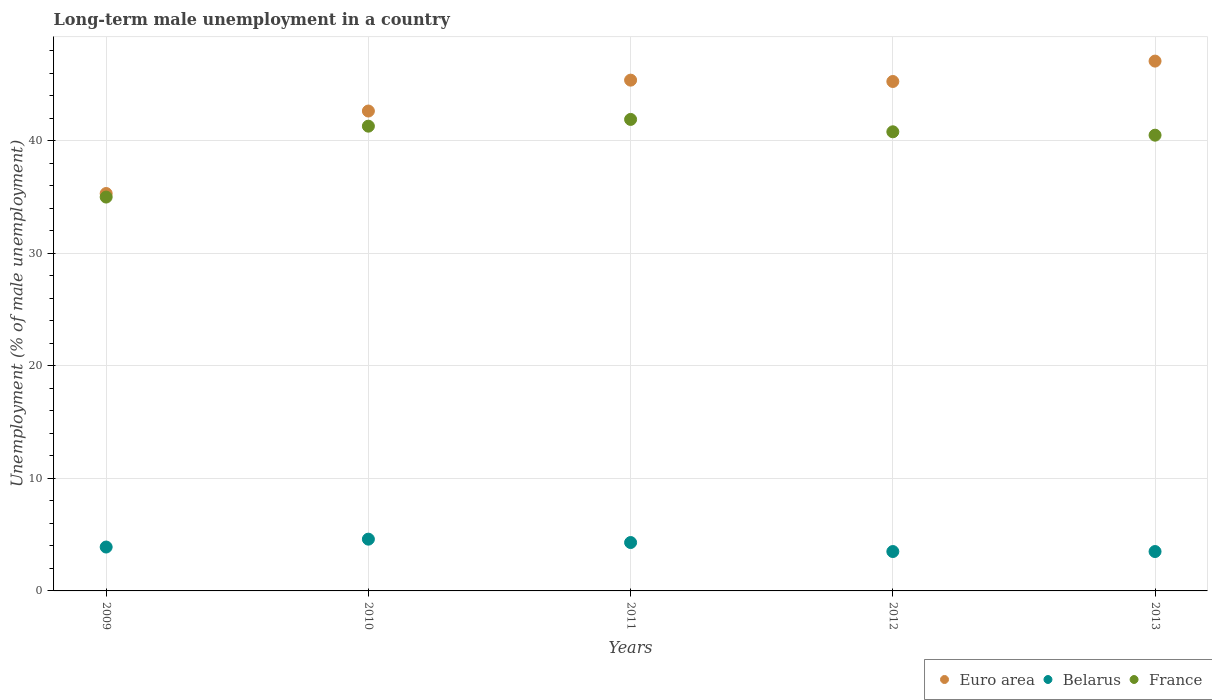What is the percentage of long-term unemployed male population in France in 2009?
Offer a terse response. 35. Across all years, what is the maximum percentage of long-term unemployed male population in France?
Make the answer very short. 41.9. Across all years, what is the minimum percentage of long-term unemployed male population in Euro area?
Keep it short and to the point. 35.32. In which year was the percentage of long-term unemployed male population in France maximum?
Your response must be concise. 2011. In which year was the percentage of long-term unemployed male population in France minimum?
Ensure brevity in your answer.  2009. What is the total percentage of long-term unemployed male population in Belarus in the graph?
Make the answer very short. 19.8. What is the difference between the percentage of long-term unemployed male population in France in 2011 and that in 2013?
Offer a very short reply. 1.4. What is the difference between the percentage of long-term unemployed male population in Euro area in 2013 and the percentage of long-term unemployed male population in France in 2009?
Offer a terse response. 12.08. What is the average percentage of long-term unemployed male population in France per year?
Provide a succinct answer. 39.9. In the year 2011, what is the difference between the percentage of long-term unemployed male population in France and percentage of long-term unemployed male population in Belarus?
Offer a terse response. 37.6. In how many years, is the percentage of long-term unemployed male population in Euro area greater than 2 %?
Offer a terse response. 5. What is the ratio of the percentage of long-term unemployed male population in Euro area in 2009 to that in 2010?
Provide a succinct answer. 0.83. Is the percentage of long-term unemployed male population in Euro area in 2011 less than that in 2013?
Provide a succinct answer. Yes. Is the difference between the percentage of long-term unemployed male population in France in 2011 and 2012 greater than the difference between the percentage of long-term unemployed male population in Belarus in 2011 and 2012?
Offer a very short reply. Yes. What is the difference between the highest and the second highest percentage of long-term unemployed male population in Euro area?
Your response must be concise. 1.69. What is the difference between the highest and the lowest percentage of long-term unemployed male population in Euro area?
Offer a very short reply. 11.77. Is it the case that in every year, the sum of the percentage of long-term unemployed male population in France and percentage of long-term unemployed male population in Euro area  is greater than the percentage of long-term unemployed male population in Belarus?
Your answer should be compact. Yes. Does the percentage of long-term unemployed male population in France monotonically increase over the years?
Offer a terse response. No. Is the percentage of long-term unemployed male population in Euro area strictly greater than the percentage of long-term unemployed male population in Belarus over the years?
Make the answer very short. Yes. Is the percentage of long-term unemployed male population in Belarus strictly less than the percentage of long-term unemployed male population in France over the years?
Offer a terse response. Yes. How many dotlines are there?
Offer a very short reply. 3. How many years are there in the graph?
Keep it short and to the point. 5. Are the values on the major ticks of Y-axis written in scientific E-notation?
Provide a succinct answer. No. Does the graph contain any zero values?
Offer a very short reply. No. Does the graph contain grids?
Offer a terse response. Yes. What is the title of the graph?
Give a very brief answer. Long-term male unemployment in a country. Does "China" appear as one of the legend labels in the graph?
Your answer should be compact. No. What is the label or title of the Y-axis?
Offer a terse response. Unemployment (% of male unemployment). What is the Unemployment (% of male unemployment) of Euro area in 2009?
Provide a short and direct response. 35.32. What is the Unemployment (% of male unemployment) of Belarus in 2009?
Your answer should be very brief. 3.9. What is the Unemployment (% of male unemployment) in Euro area in 2010?
Offer a very short reply. 42.65. What is the Unemployment (% of male unemployment) in Belarus in 2010?
Offer a very short reply. 4.6. What is the Unemployment (% of male unemployment) of France in 2010?
Keep it short and to the point. 41.3. What is the Unemployment (% of male unemployment) in Euro area in 2011?
Give a very brief answer. 45.39. What is the Unemployment (% of male unemployment) in Belarus in 2011?
Your answer should be very brief. 4.3. What is the Unemployment (% of male unemployment) in France in 2011?
Give a very brief answer. 41.9. What is the Unemployment (% of male unemployment) of Euro area in 2012?
Provide a succinct answer. 45.27. What is the Unemployment (% of male unemployment) of France in 2012?
Provide a succinct answer. 40.8. What is the Unemployment (% of male unemployment) of Euro area in 2013?
Your answer should be very brief. 47.08. What is the Unemployment (% of male unemployment) in Belarus in 2013?
Make the answer very short. 3.5. What is the Unemployment (% of male unemployment) in France in 2013?
Offer a very short reply. 40.5. Across all years, what is the maximum Unemployment (% of male unemployment) in Euro area?
Make the answer very short. 47.08. Across all years, what is the maximum Unemployment (% of male unemployment) in Belarus?
Make the answer very short. 4.6. Across all years, what is the maximum Unemployment (% of male unemployment) in France?
Make the answer very short. 41.9. Across all years, what is the minimum Unemployment (% of male unemployment) in Euro area?
Keep it short and to the point. 35.32. What is the total Unemployment (% of male unemployment) of Euro area in the graph?
Your answer should be compact. 215.7. What is the total Unemployment (% of male unemployment) of Belarus in the graph?
Give a very brief answer. 19.8. What is the total Unemployment (% of male unemployment) in France in the graph?
Your response must be concise. 199.5. What is the difference between the Unemployment (% of male unemployment) of Euro area in 2009 and that in 2010?
Your response must be concise. -7.33. What is the difference between the Unemployment (% of male unemployment) in Euro area in 2009 and that in 2011?
Offer a very short reply. -10.07. What is the difference between the Unemployment (% of male unemployment) of Euro area in 2009 and that in 2012?
Keep it short and to the point. -9.96. What is the difference between the Unemployment (% of male unemployment) in Belarus in 2009 and that in 2012?
Your response must be concise. 0.4. What is the difference between the Unemployment (% of male unemployment) in Euro area in 2009 and that in 2013?
Provide a short and direct response. -11.77. What is the difference between the Unemployment (% of male unemployment) of Euro area in 2010 and that in 2011?
Make the answer very short. -2.74. What is the difference between the Unemployment (% of male unemployment) in Belarus in 2010 and that in 2011?
Provide a succinct answer. 0.3. What is the difference between the Unemployment (% of male unemployment) of France in 2010 and that in 2011?
Offer a terse response. -0.6. What is the difference between the Unemployment (% of male unemployment) of Euro area in 2010 and that in 2012?
Ensure brevity in your answer.  -2.63. What is the difference between the Unemployment (% of male unemployment) in Euro area in 2010 and that in 2013?
Provide a short and direct response. -4.44. What is the difference between the Unemployment (% of male unemployment) in Euro area in 2011 and that in 2012?
Ensure brevity in your answer.  0.12. What is the difference between the Unemployment (% of male unemployment) in Belarus in 2011 and that in 2012?
Make the answer very short. 0.8. What is the difference between the Unemployment (% of male unemployment) of France in 2011 and that in 2012?
Provide a short and direct response. 1.1. What is the difference between the Unemployment (% of male unemployment) of Euro area in 2011 and that in 2013?
Ensure brevity in your answer.  -1.69. What is the difference between the Unemployment (% of male unemployment) in Euro area in 2012 and that in 2013?
Your response must be concise. -1.81. What is the difference between the Unemployment (% of male unemployment) in Belarus in 2012 and that in 2013?
Give a very brief answer. 0. What is the difference between the Unemployment (% of male unemployment) in Euro area in 2009 and the Unemployment (% of male unemployment) in Belarus in 2010?
Provide a short and direct response. 30.72. What is the difference between the Unemployment (% of male unemployment) of Euro area in 2009 and the Unemployment (% of male unemployment) of France in 2010?
Your response must be concise. -5.98. What is the difference between the Unemployment (% of male unemployment) in Belarus in 2009 and the Unemployment (% of male unemployment) in France in 2010?
Offer a terse response. -37.4. What is the difference between the Unemployment (% of male unemployment) of Euro area in 2009 and the Unemployment (% of male unemployment) of Belarus in 2011?
Your answer should be compact. 31.02. What is the difference between the Unemployment (% of male unemployment) of Euro area in 2009 and the Unemployment (% of male unemployment) of France in 2011?
Ensure brevity in your answer.  -6.58. What is the difference between the Unemployment (% of male unemployment) in Belarus in 2009 and the Unemployment (% of male unemployment) in France in 2011?
Offer a terse response. -38. What is the difference between the Unemployment (% of male unemployment) in Euro area in 2009 and the Unemployment (% of male unemployment) in Belarus in 2012?
Provide a short and direct response. 31.82. What is the difference between the Unemployment (% of male unemployment) in Euro area in 2009 and the Unemployment (% of male unemployment) in France in 2012?
Offer a very short reply. -5.48. What is the difference between the Unemployment (% of male unemployment) in Belarus in 2009 and the Unemployment (% of male unemployment) in France in 2012?
Provide a short and direct response. -36.9. What is the difference between the Unemployment (% of male unemployment) of Euro area in 2009 and the Unemployment (% of male unemployment) of Belarus in 2013?
Make the answer very short. 31.82. What is the difference between the Unemployment (% of male unemployment) of Euro area in 2009 and the Unemployment (% of male unemployment) of France in 2013?
Offer a terse response. -5.18. What is the difference between the Unemployment (% of male unemployment) of Belarus in 2009 and the Unemployment (% of male unemployment) of France in 2013?
Keep it short and to the point. -36.6. What is the difference between the Unemployment (% of male unemployment) of Euro area in 2010 and the Unemployment (% of male unemployment) of Belarus in 2011?
Offer a terse response. 38.35. What is the difference between the Unemployment (% of male unemployment) in Euro area in 2010 and the Unemployment (% of male unemployment) in France in 2011?
Ensure brevity in your answer.  0.75. What is the difference between the Unemployment (% of male unemployment) in Belarus in 2010 and the Unemployment (% of male unemployment) in France in 2011?
Give a very brief answer. -37.3. What is the difference between the Unemployment (% of male unemployment) of Euro area in 2010 and the Unemployment (% of male unemployment) of Belarus in 2012?
Your answer should be compact. 39.15. What is the difference between the Unemployment (% of male unemployment) in Euro area in 2010 and the Unemployment (% of male unemployment) in France in 2012?
Make the answer very short. 1.85. What is the difference between the Unemployment (% of male unemployment) of Belarus in 2010 and the Unemployment (% of male unemployment) of France in 2012?
Your response must be concise. -36.2. What is the difference between the Unemployment (% of male unemployment) of Euro area in 2010 and the Unemployment (% of male unemployment) of Belarus in 2013?
Ensure brevity in your answer.  39.15. What is the difference between the Unemployment (% of male unemployment) of Euro area in 2010 and the Unemployment (% of male unemployment) of France in 2013?
Ensure brevity in your answer.  2.15. What is the difference between the Unemployment (% of male unemployment) in Belarus in 2010 and the Unemployment (% of male unemployment) in France in 2013?
Provide a succinct answer. -35.9. What is the difference between the Unemployment (% of male unemployment) in Euro area in 2011 and the Unemployment (% of male unemployment) in Belarus in 2012?
Your response must be concise. 41.89. What is the difference between the Unemployment (% of male unemployment) of Euro area in 2011 and the Unemployment (% of male unemployment) of France in 2012?
Make the answer very short. 4.59. What is the difference between the Unemployment (% of male unemployment) of Belarus in 2011 and the Unemployment (% of male unemployment) of France in 2012?
Offer a very short reply. -36.5. What is the difference between the Unemployment (% of male unemployment) in Euro area in 2011 and the Unemployment (% of male unemployment) in Belarus in 2013?
Offer a very short reply. 41.89. What is the difference between the Unemployment (% of male unemployment) of Euro area in 2011 and the Unemployment (% of male unemployment) of France in 2013?
Provide a succinct answer. 4.89. What is the difference between the Unemployment (% of male unemployment) of Belarus in 2011 and the Unemployment (% of male unemployment) of France in 2013?
Your answer should be compact. -36.2. What is the difference between the Unemployment (% of male unemployment) in Euro area in 2012 and the Unemployment (% of male unemployment) in Belarus in 2013?
Your answer should be compact. 41.77. What is the difference between the Unemployment (% of male unemployment) in Euro area in 2012 and the Unemployment (% of male unemployment) in France in 2013?
Keep it short and to the point. 4.77. What is the difference between the Unemployment (% of male unemployment) of Belarus in 2012 and the Unemployment (% of male unemployment) of France in 2013?
Make the answer very short. -37. What is the average Unemployment (% of male unemployment) in Euro area per year?
Keep it short and to the point. 43.14. What is the average Unemployment (% of male unemployment) of Belarus per year?
Offer a very short reply. 3.96. What is the average Unemployment (% of male unemployment) of France per year?
Your answer should be compact. 39.9. In the year 2009, what is the difference between the Unemployment (% of male unemployment) of Euro area and Unemployment (% of male unemployment) of Belarus?
Your answer should be very brief. 31.42. In the year 2009, what is the difference between the Unemployment (% of male unemployment) of Euro area and Unemployment (% of male unemployment) of France?
Ensure brevity in your answer.  0.32. In the year 2009, what is the difference between the Unemployment (% of male unemployment) of Belarus and Unemployment (% of male unemployment) of France?
Provide a succinct answer. -31.1. In the year 2010, what is the difference between the Unemployment (% of male unemployment) of Euro area and Unemployment (% of male unemployment) of Belarus?
Provide a short and direct response. 38.05. In the year 2010, what is the difference between the Unemployment (% of male unemployment) of Euro area and Unemployment (% of male unemployment) of France?
Ensure brevity in your answer.  1.35. In the year 2010, what is the difference between the Unemployment (% of male unemployment) of Belarus and Unemployment (% of male unemployment) of France?
Give a very brief answer. -36.7. In the year 2011, what is the difference between the Unemployment (% of male unemployment) of Euro area and Unemployment (% of male unemployment) of Belarus?
Give a very brief answer. 41.09. In the year 2011, what is the difference between the Unemployment (% of male unemployment) in Euro area and Unemployment (% of male unemployment) in France?
Offer a very short reply. 3.49. In the year 2011, what is the difference between the Unemployment (% of male unemployment) in Belarus and Unemployment (% of male unemployment) in France?
Your answer should be compact. -37.6. In the year 2012, what is the difference between the Unemployment (% of male unemployment) of Euro area and Unemployment (% of male unemployment) of Belarus?
Make the answer very short. 41.77. In the year 2012, what is the difference between the Unemployment (% of male unemployment) of Euro area and Unemployment (% of male unemployment) of France?
Provide a succinct answer. 4.47. In the year 2012, what is the difference between the Unemployment (% of male unemployment) of Belarus and Unemployment (% of male unemployment) of France?
Make the answer very short. -37.3. In the year 2013, what is the difference between the Unemployment (% of male unemployment) in Euro area and Unemployment (% of male unemployment) in Belarus?
Keep it short and to the point. 43.58. In the year 2013, what is the difference between the Unemployment (% of male unemployment) in Euro area and Unemployment (% of male unemployment) in France?
Make the answer very short. 6.58. In the year 2013, what is the difference between the Unemployment (% of male unemployment) in Belarus and Unemployment (% of male unemployment) in France?
Offer a very short reply. -37. What is the ratio of the Unemployment (% of male unemployment) of Euro area in 2009 to that in 2010?
Offer a terse response. 0.83. What is the ratio of the Unemployment (% of male unemployment) of Belarus in 2009 to that in 2010?
Make the answer very short. 0.85. What is the ratio of the Unemployment (% of male unemployment) in France in 2009 to that in 2010?
Give a very brief answer. 0.85. What is the ratio of the Unemployment (% of male unemployment) in Euro area in 2009 to that in 2011?
Provide a succinct answer. 0.78. What is the ratio of the Unemployment (% of male unemployment) in Belarus in 2009 to that in 2011?
Offer a very short reply. 0.91. What is the ratio of the Unemployment (% of male unemployment) of France in 2009 to that in 2011?
Make the answer very short. 0.84. What is the ratio of the Unemployment (% of male unemployment) of Euro area in 2009 to that in 2012?
Your answer should be very brief. 0.78. What is the ratio of the Unemployment (% of male unemployment) in Belarus in 2009 to that in 2012?
Make the answer very short. 1.11. What is the ratio of the Unemployment (% of male unemployment) in France in 2009 to that in 2012?
Provide a succinct answer. 0.86. What is the ratio of the Unemployment (% of male unemployment) in Euro area in 2009 to that in 2013?
Make the answer very short. 0.75. What is the ratio of the Unemployment (% of male unemployment) in Belarus in 2009 to that in 2013?
Provide a short and direct response. 1.11. What is the ratio of the Unemployment (% of male unemployment) in France in 2009 to that in 2013?
Ensure brevity in your answer.  0.86. What is the ratio of the Unemployment (% of male unemployment) of Euro area in 2010 to that in 2011?
Offer a terse response. 0.94. What is the ratio of the Unemployment (% of male unemployment) in Belarus in 2010 to that in 2011?
Provide a succinct answer. 1.07. What is the ratio of the Unemployment (% of male unemployment) in France in 2010 to that in 2011?
Your response must be concise. 0.99. What is the ratio of the Unemployment (% of male unemployment) of Euro area in 2010 to that in 2012?
Your response must be concise. 0.94. What is the ratio of the Unemployment (% of male unemployment) in Belarus in 2010 to that in 2012?
Provide a short and direct response. 1.31. What is the ratio of the Unemployment (% of male unemployment) in France in 2010 to that in 2012?
Provide a succinct answer. 1.01. What is the ratio of the Unemployment (% of male unemployment) in Euro area in 2010 to that in 2013?
Your answer should be compact. 0.91. What is the ratio of the Unemployment (% of male unemployment) in Belarus in 2010 to that in 2013?
Your response must be concise. 1.31. What is the ratio of the Unemployment (% of male unemployment) in France in 2010 to that in 2013?
Offer a very short reply. 1.02. What is the ratio of the Unemployment (% of male unemployment) of Euro area in 2011 to that in 2012?
Provide a succinct answer. 1. What is the ratio of the Unemployment (% of male unemployment) of Belarus in 2011 to that in 2012?
Provide a short and direct response. 1.23. What is the ratio of the Unemployment (% of male unemployment) in Euro area in 2011 to that in 2013?
Offer a very short reply. 0.96. What is the ratio of the Unemployment (% of male unemployment) in Belarus in 2011 to that in 2013?
Offer a terse response. 1.23. What is the ratio of the Unemployment (% of male unemployment) in France in 2011 to that in 2013?
Offer a very short reply. 1.03. What is the ratio of the Unemployment (% of male unemployment) of Euro area in 2012 to that in 2013?
Make the answer very short. 0.96. What is the ratio of the Unemployment (% of male unemployment) in Belarus in 2012 to that in 2013?
Offer a very short reply. 1. What is the ratio of the Unemployment (% of male unemployment) of France in 2012 to that in 2013?
Offer a terse response. 1.01. What is the difference between the highest and the second highest Unemployment (% of male unemployment) of Euro area?
Provide a short and direct response. 1.69. What is the difference between the highest and the second highest Unemployment (% of male unemployment) of Belarus?
Make the answer very short. 0.3. What is the difference between the highest and the second highest Unemployment (% of male unemployment) in France?
Offer a very short reply. 0.6. What is the difference between the highest and the lowest Unemployment (% of male unemployment) in Euro area?
Provide a succinct answer. 11.77. What is the difference between the highest and the lowest Unemployment (% of male unemployment) of Belarus?
Make the answer very short. 1.1. 